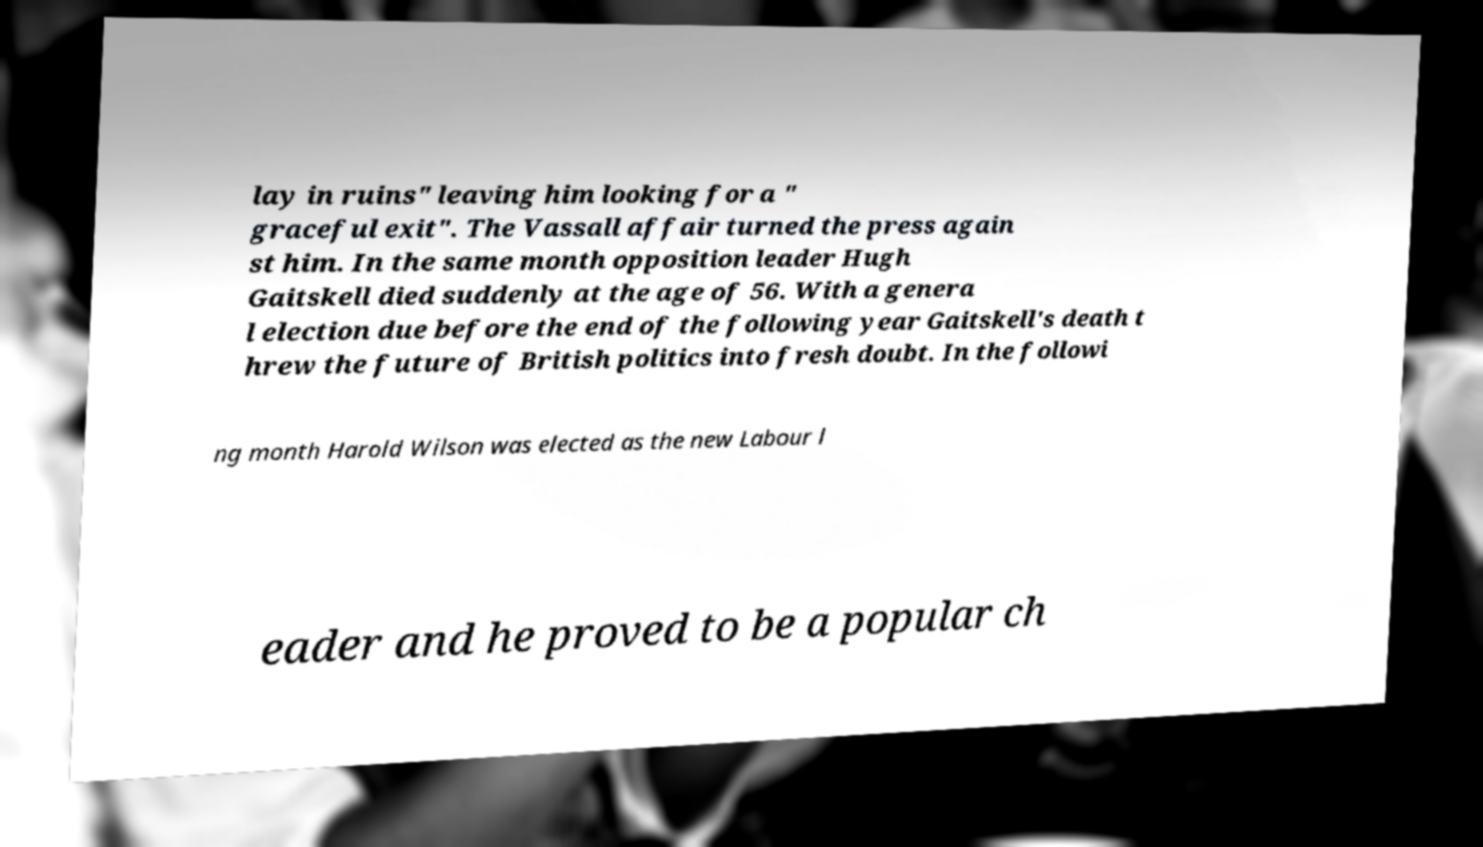There's text embedded in this image that I need extracted. Can you transcribe it verbatim? lay in ruins" leaving him looking for a " graceful exit". The Vassall affair turned the press again st him. In the same month opposition leader Hugh Gaitskell died suddenly at the age of 56. With a genera l election due before the end of the following year Gaitskell's death t hrew the future of British politics into fresh doubt. In the followi ng month Harold Wilson was elected as the new Labour l eader and he proved to be a popular ch 